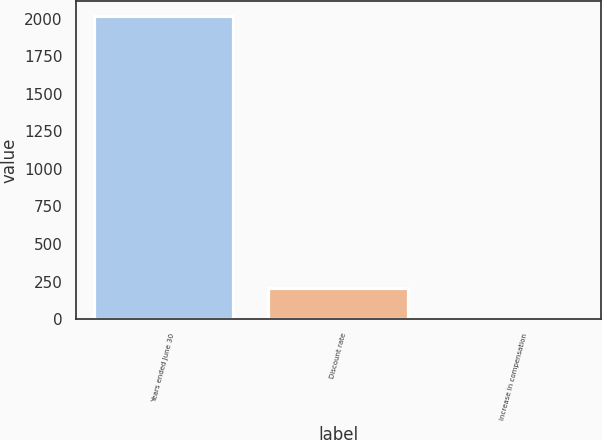Convert chart to OTSL. <chart><loc_0><loc_0><loc_500><loc_500><bar_chart><fcel>Years ended June 30<fcel>Discount rate<fcel>Increase in compensation<nl><fcel>2018<fcel>205.4<fcel>4<nl></chart> 